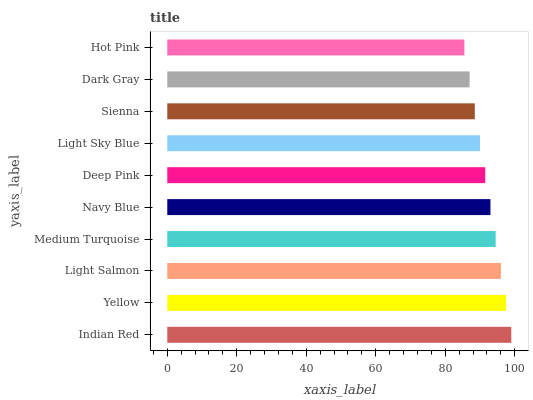Is Hot Pink the minimum?
Answer yes or no. Yes. Is Indian Red the maximum?
Answer yes or no. Yes. Is Yellow the minimum?
Answer yes or no. No. Is Yellow the maximum?
Answer yes or no. No. Is Indian Red greater than Yellow?
Answer yes or no. Yes. Is Yellow less than Indian Red?
Answer yes or no. Yes. Is Yellow greater than Indian Red?
Answer yes or no. No. Is Indian Red less than Yellow?
Answer yes or no. No. Is Navy Blue the high median?
Answer yes or no. Yes. Is Deep Pink the low median?
Answer yes or no. Yes. Is Hot Pink the high median?
Answer yes or no. No. Is Navy Blue the low median?
Answer yes or no. No. 